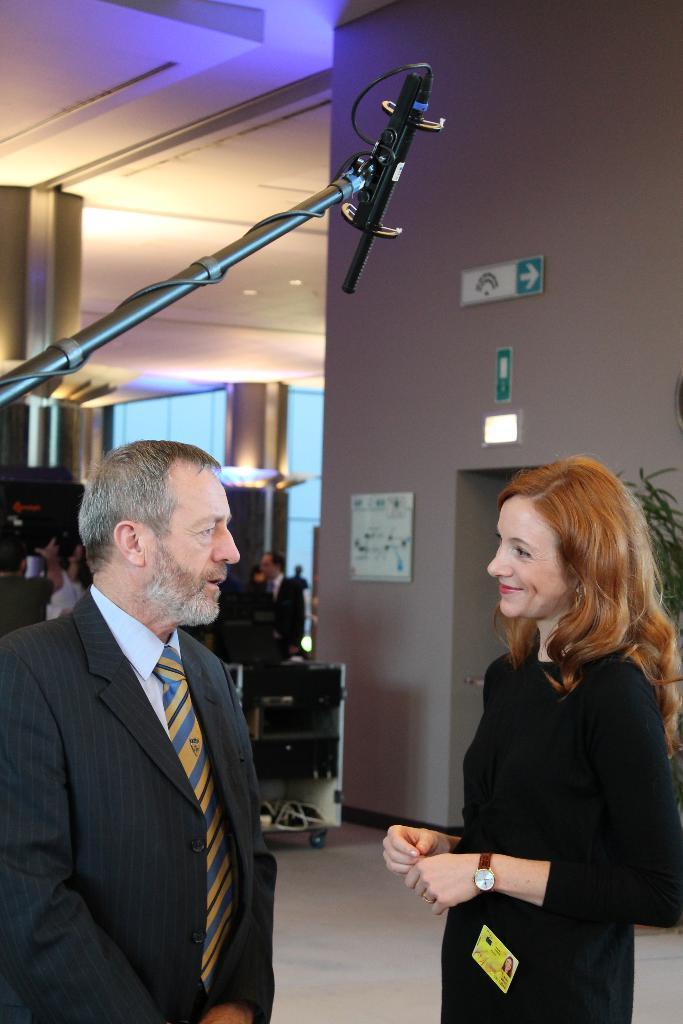Could you give a brief overview of what you see in this image? In this image we can see people standing on the floor, sign boards, information boards, houseplants, electric lights and walls. 